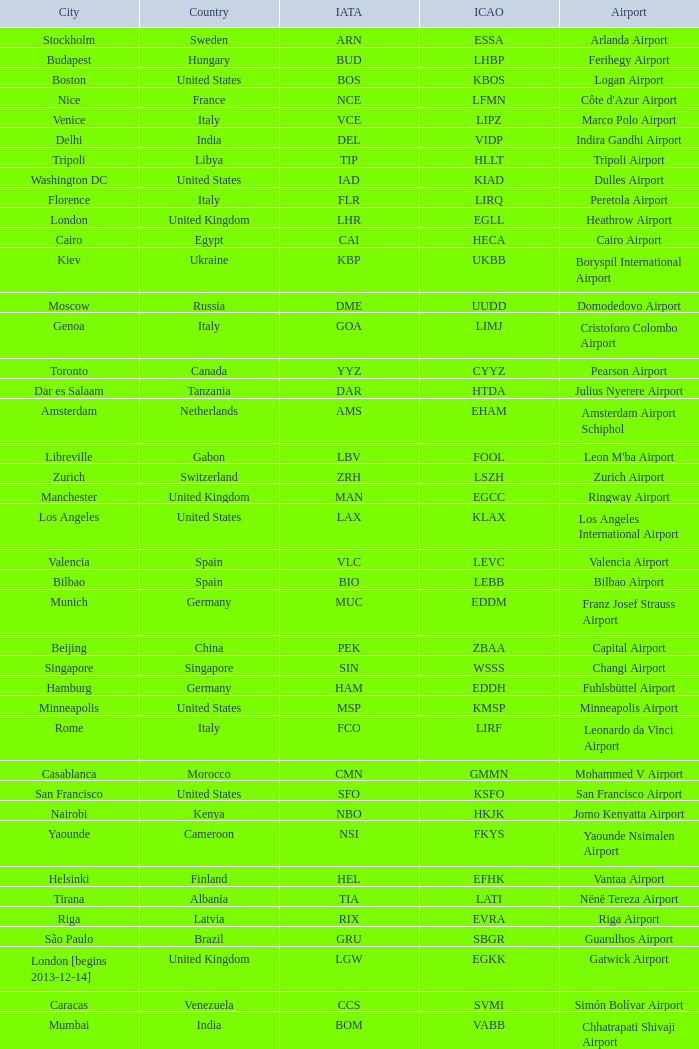What is the ICAO of Lohausen airport? EDDL. 